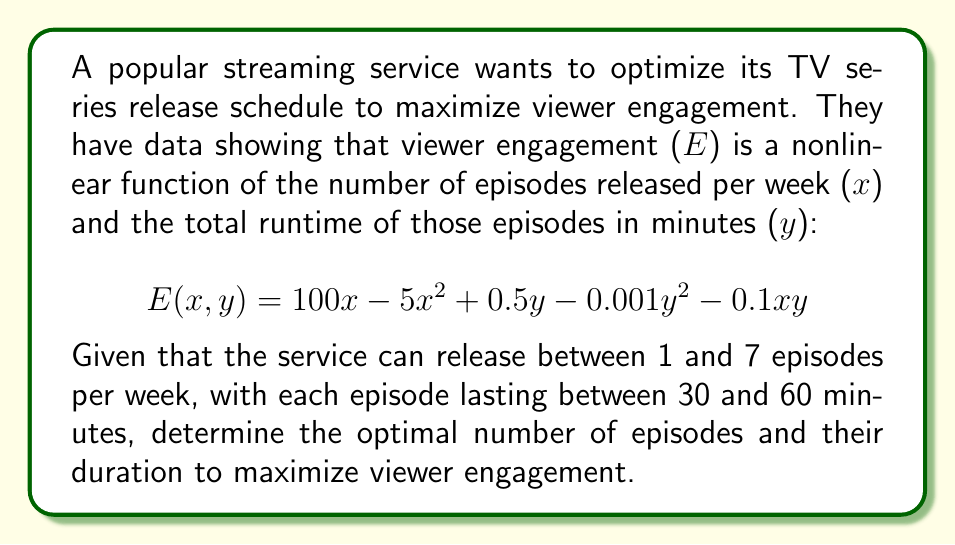Provide a solution to this math problem. To solve this nonlinear optimization problem, we'll follow these steps:

1. Identify the objective function and constraints:
   Objective function: $E(x,y) = 100x - 5x^2 + 0.5y - 0.001y^2 - 0.1xy$
   Constraints: $1 \leq x \leq 7$ and $30x \leq y \leq 60x$

2. Find the critical points by taking partial derivatives:
   $\frac{\partial E}{\partial x} = 100 - 10x + 0.5y - 0.1y = 0$
   $\frac{\partial E}{\partial y} = 0.5 - 0.002y - 0.1x = 0$

3. Solve the system of equations:
   From the second equation: $y = 250 - 50x$
   Substituting into the first equation:
   $100 - 10x + 0.5(250 - 50x) - 0.1(250 - 50x) = 0$
   $100 - 10x + 125 - 25x - 25 + 5x = 0$
   $200 - 30x = 0$
   $x = \frac{20}{3} \approx 6.67$

4. Check the constraints:
   $1 \leq x \leq 7$ is satisfied
   $y = 250 - 50x = 250 - 50(\frac{20}{3}) \approx 83.33$
   $30x \leq y \leq 60x$ is not satisfied as $83.33 > 60(\frac{20}{3})$

5. Since the unconstrained optimum doesn't satisfy all constraints, we need to check the boundaries:
   For $x = 7$ (max episodes):
   $30 \leq y \leq 420$, optimal $y = 250 - 50(7) = 100$
   $E(7, 100) = 700 - 245 + 50 - 10 - 70 = 425$

   For $y = 60x$ (max duration):
   $E(x, 60x) = 100x - 5x^2 + 30x - 3.6x^2 - 6x^2$
   $\frac{dE}{dx} = 100 + 30 - 10x - 7.2x - 12x = 0$
   $130 = 29.2x$
   $x \approx 4.45$, which satisfies $1 \leq x \leq 7$
   $y = 60(4.45) = 267$
   $E(4.45, 267) \approx 444.5$

6. Compare the results:
   $E(7, 100) = 425$
   $E(4.45, 267) \approx 444.5$

The maximum viewer engagement is achieved with approximately 4.45 episodes per week, each with a duration of 60 minutes.
Answer: 4.45 episodes per week, 60 minutes each 